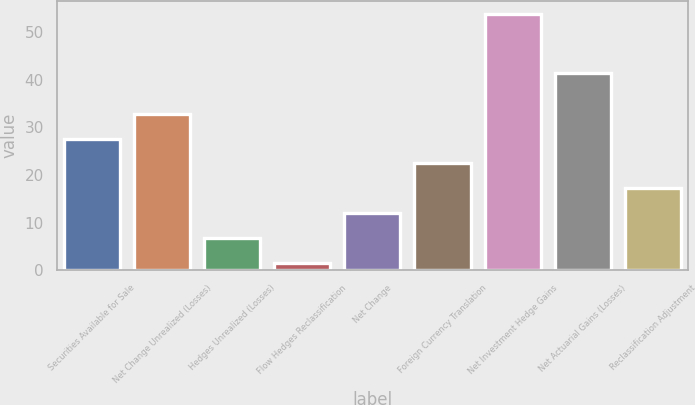<chart> <loc_0><loc_0><loc_500><loc_500><bar_chart><fcel>Securities Available for Sale<fcel>Net Change Unrealized (Losses)<fcel>Hedges Unrealized (Losses)<fcel>Flow Hedges Reclassification<fcel>Net Change<fcel>Foreign Currency Translation<fcel>Net Investment Hedge Gains<fcel>Net Actuarial Gains (Losses)<fcel>Reclassification Adjustment<nl><fcel>27.65<fcel>32.88<fcel>6.73<fcel>1.5<fcel>11.96<fcel>22.42<fcel>53.8<fcel>41.5<fcel>17.19<nl></chart> 